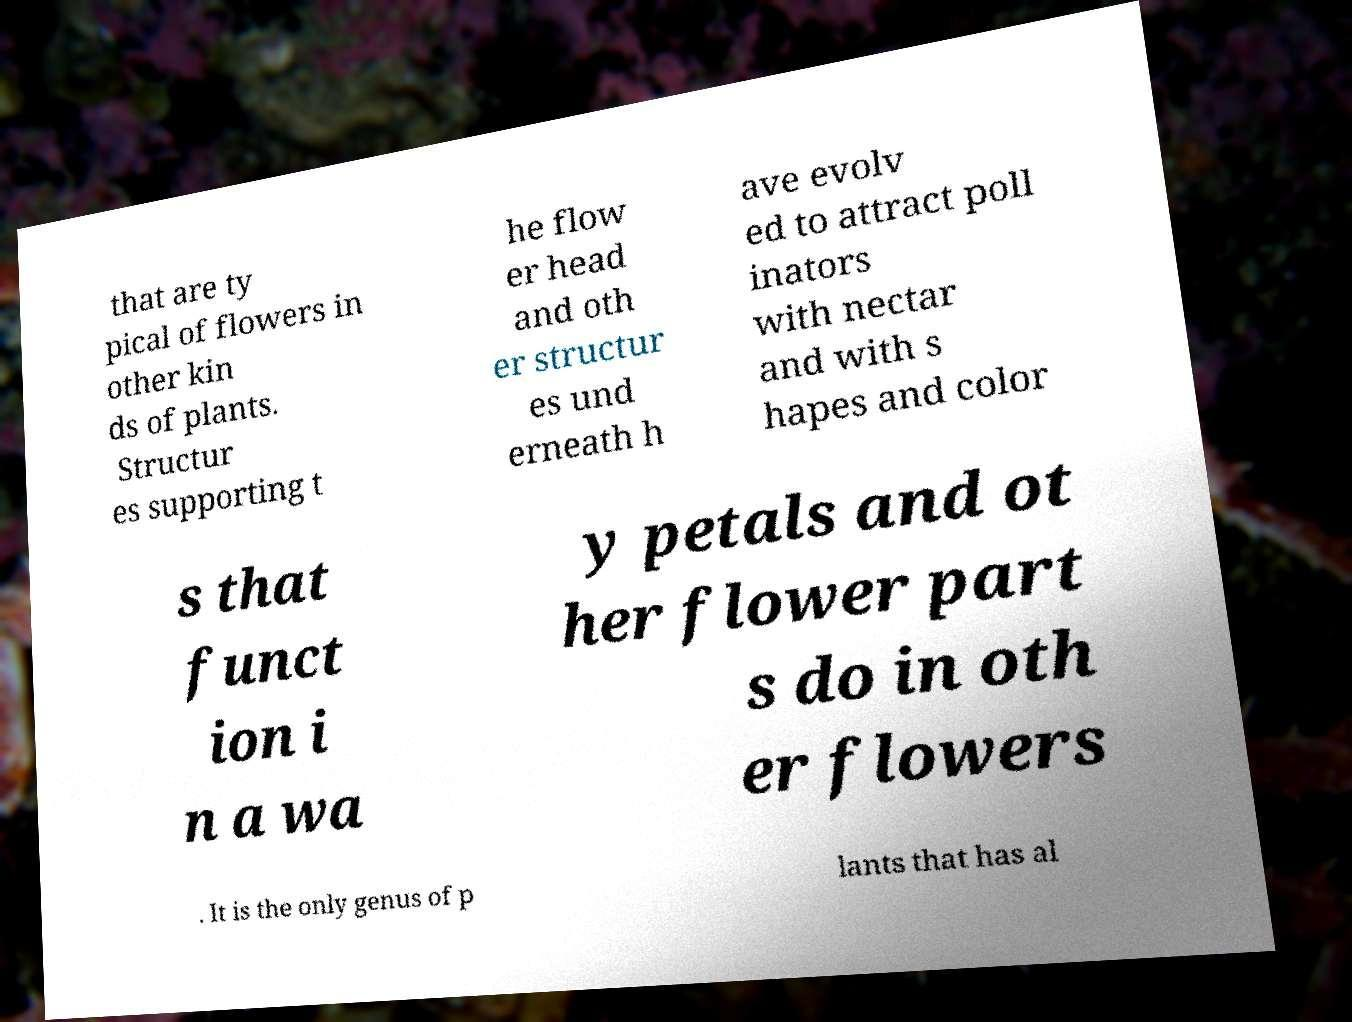Could you assist in decoding the text presented in this image and type it out clearly? that are ty pical of flowers in other kin ds of plants. Structur es supporting t he flow er head and oth er structur es und erneath h ave evolv ed to attract poll inators with nectar and with s hapes and color s that funct ion i n a wa y petals and ot her flower part s do in oth er flowers . It is the only genus of p lants that has al 